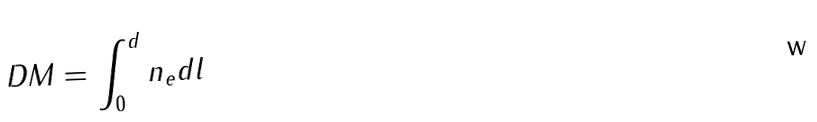Convert formula to latex. <formula><loc_0><loc_0><loc_500><loc_500>D M = \int _ { 0 } ^ { d } n _ { e } d l</formula> 